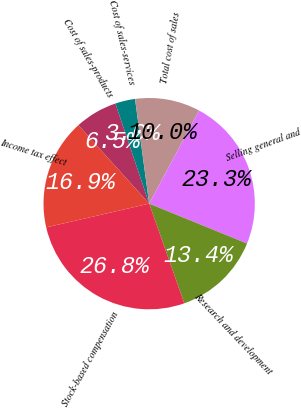<chart> <loc_0><loc_0><loc_500><loc_500><pie_chart><fcel>Cost of sales-products<fcel>Cost of sales-services<fcel>Total cost of sales<fcel>Selling general and<fcel>Research and development<fcel>Stock-based compensation<fcel>Income tax effect<nl><fcel>6.51%<fcel>3.04%<fcel>9.98%<fcel>23.32%<fcel>13.45%<fcel>26.79%<fcel>16.92%<nl></chart> 